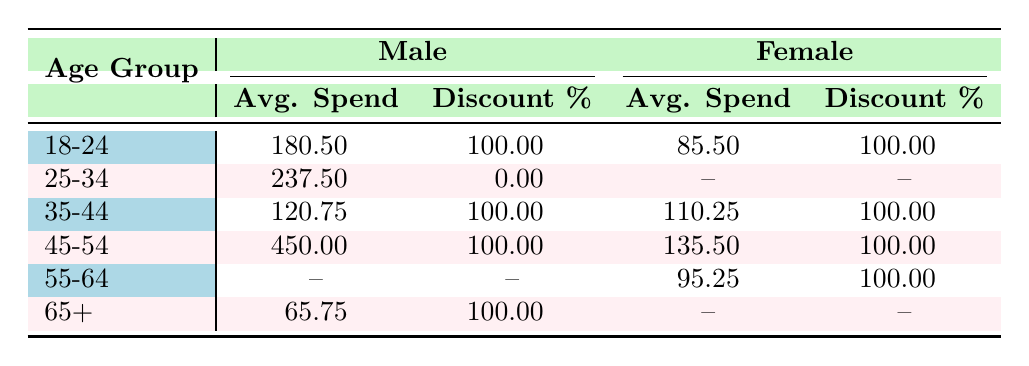What is the average spend for males in the age group 18-24? The table shows that for the age group 18-24, the average spend for males is listed as 180.50.
Answer: 180.50 What is the discount percentage for females aged 35-44? The table indicates that the discount percentage for females in the age group 35-44 is 100.00.
Answer: 100.00 Is there any male customer in the age group 55-64 who redeemed a discount? The table does not provide data on male customers in the age group 55-64 who redeemed a discount, marked as {--} for both average spend and discount percentage.
Answer: No What is the total average spend for all customers who redeemed discounts? To find the total average spend, we only consider rows where discount redeemed is true (18-24 females, 35-44 males and females, 45-54 males and females, 65+ males). The average spend values are 180.50 + 120.75 + 110.25 + 450.00 + 135.50 + 65.75 = 1,063.75, and there are 6 entries. Calculating the average gives 1,063.75 / 6 = 176.29.
Answer: 176.29 Which age group has the highest average spend for males who redeemed discounts? The table shows that the age group 45-54 has the highest average spend for males at 450.00.
Answer: 45-54 What is the average discount percentage for all females? In the table, the average discount percentage for females in age groups 18-24 (100.00), 35-44 (100.00), 45-54 (100.00), and 55-64 (100.00) is calculated as (100 + 100 + 100 + 100) / 4 = 100.00.
Answer: 100.00 Did any customer lose the opportunity to redeem a discount in the age group 25-34? In the table, it shows that no female customer in the age group 25-34 redeemed a discount, as marked with {--}.
Answer: Yes What are the average spends for males and females in the group 65+? The table shows the average spend for males in the age group 65+ is 65.75, while for females, it is marked as {--}, indicating no data available. Thus, the average spend is 65.75 for males and no data for females.
Answer: 65.75 for males; no data for females 